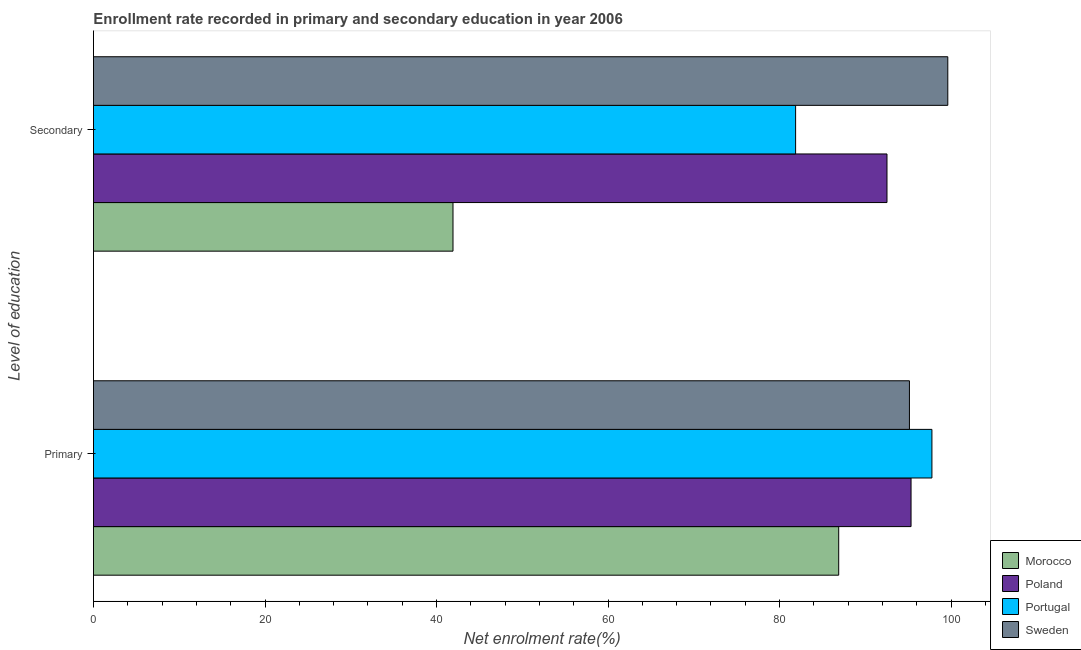How many different coloured bars are there?
Make the answer very short. 4. What is the label of the 1st group of bars from the top?
Keep it short and to the point. Secondary. What is the enrollment rate in primary education in Poland?
Provide a succinct answer. 95.33. Across all countries, what is the maximum enrollment rate in secondary education?
Offer a very short reply. 99.61. Across all countries, what is the minimum enrollment rate in primary education?
Offer a terse response. 86.89. In which country was the enrollment rate in primary education minimum?
Provide a short and direct response. Morocco. What is the total enrollment rate in primary education in the graph?
Your response must be concise. 375.13. What is the difference between the enrollment rate in primary education in Poland and that in Sweden?
Offer a terse response. 0.19. What is the difference between the enrollment rate in primary education in Poland and the enrollment rate in secondary education in Portugal?
Keep it short and to the point. 13.46. What is the average enrollment rate in primary education per country?
Keep it short and to the point. 93.78. What is the difference between the enrollment rate in secondary education and enrollment rate in primary education in Portugal?
Your answer should be compact. -15.89. What is the ratio of the enrollment rate in primary education in Morocco to that in Portugal?
Provide a succinct answer. 0.89. What does the 4th bar from the top in Primary represents?
Keep it short and to the point. Morocco. How many bars are there?
Your response must be concise. 8. How many countries are there in the graph?
Keep it short and to the point. 4. What is the difference between two consecutive major ticks on the X-axis?
Provide a succinct answer. 20. Does the graph contain grids?
Ensure brevity in your answer.  No. Where does the legend appear in the graph?
Ensure brevity in your answer.  Bottom right. What is the title of the graph?
Offer a terse response. Enrollment rate recorded in primary and secondary education in year 2006. What is the label or title of the X-axis?
Your answer should be compact. Net enrolment rate(%). What is the label or title of the Y-axis?
Your response must be concise. Level of education. What is the Net enrolment rate(%) in Morocco in Primary?
Provide a succinct answer. 86.89. What is the Net enrolment rate(%) of Poland in Primary?
Your response must be concise. 95.33. What is the Net enrolment rate(%) of Portugal in Primary?
Your answer should be very brief. 97.76. What is the Net enrolment rate(%) of Sweden in Primary?
Keep it short and to the point. 95.14. What is the Net enrolment rate(%) in Morocco in Secondary?
Make the answer very short. 41.92. What is the Net enrolment rate(%) of Poland in Secondary?
Your answer should be very brief. 92.52. What is the Net enrolment rate(%) of Portugal in Secondary?
Offer a terse response. 81.87. What is the Net enrolment rate(%) in Sweden in Secondary?
Provide a short and direct response. 99.61. Across all Level of education, what is the maximum Net enrolment rate(%) in Morocco?
Give a very brief answer. 86.89. Across all Level of education, what is the maximum Net enrolment rate(%) of Poland?
Give a very brief answer. 95.33. Across all Level of education, what is the maximum Net enrolment rate(%) of Portugal?
Your answer should be compact. 97.76. Across all Level of education, what is the maximum Net enrolment rate(%) of Sweden?
Offer a terse response. 99.61. Across all Level of education, what is the minimum Net enrolment rate(%) in Morocco?
Give a very brief answer. 41.92. Across all Level of education, what is the minimum Net enrolment rate(%) in Poland?
Your answer should be very brief. 92.52. Across all Level of education, what is the minimum Net enrolment rate(%) of Portugal?
Your answer should be very brief. 81.87. Across all Level of education, what is the minimum Net enrolment rate(%) of Sweden?
Offer a very short reply. 95.14. What is the total Net enrolment rate(%) in Morocco in the graph?
Offer a terse response. 128.82. What is the total Net enrolment rate(%) of Poland in the graph?
Ensure brevity in your answer.  187.85. What is the total Net enrolment rate(%) of Portugal in the graph?
Make the answer very short. 179.63. What is the total Net enrolment rate(%) of Sweden in the graph?
Ensure brevity in your answer.  194.76. What is the difference between the Net enrolment rate(%) in Morocco in Primary and that in Secondary?
Keep it short and to the point. 44.97. What is the difference between the Net enrolment rate(%) of Poland in Primary and that in Secondary?
Provide a short and direct response. 2.81. What is the difference between the Net enrolment rate(%) in Portugal in Primary and that in Secondary?
Provide a short and direct response. 15.89. What is the difference between the Net enrolment rate(%) of Sweden in Primary and that in Secondary?
Your response must be concise. -4.47. What is the difference between the Net enrolment rate(%) in Morocco in Primary and the Net enrolment rate(%) in Poland in Secondary?
Provide a short and direct response. -5.63. What is the difference between the Net enrolment rate(%) in Morocco in Primary and the Net enrolment rate(%) in Portugal in Secondary?
Your response must be concise. 5.02. What is the difference between the Net enrolment rate(%) of Morocco in Primary and the Net enrolment rate(%) of Sweden in Secondary?
Provide a short and direct response. -12.72. What is the difference between the Net enrolment rate(%) of Poland in Primary and the Net enrolment rate(%) of Portugal in Secondary?
Give a very brief answer. 13.46. What is the difference between the Net enrolment rate(%) of Poland in Primary and the Net enrolment rate(%) of Sweden in Secondary?
Ensure brevity in your answer.  -4.29. What is the difference between the Net enrolment rate(%) in Portugal in Primary and the Net enrolment rate(%) in Sweden in Secondary?
Give a very brief answer. -1.85. What is the average Net enrolment rate(%) of Morocco per Level of education?
Ensure brevity in your answer.  64.41. What is the average Net enrolment rate(%) in Poland per Level of education?
Your response must be concise. 93.93. What is the average Net enrolment rate(%) in Portugal per Level of education?
Ensure brevity in your answer.  89.82. What is the average Net enrolment rate(%) in Sweden per Level of education?
Ensure brevity in your answer.  97.38. What is the difference between the Net enrolment rate(%) of Morocco and Net enrolment rate(%) of Poland in Primary?
Your answer should be very brief. -8.44. What is the difference between the Net enrolment rate(%) of Morocco and Net enrolment rate(%) of Portugal in Primary?
Your response must be concise. -10.87. What is the difference between the Net enrolment rate(%) in Morocco and Net enrolment rate(%) in Sweden in Primary?
Make the answer very short. -8.25. What is the difference between the Net enrolment rate(%) of Poland and Net enrolment rate(%) of Portugal in Primary?
Provide a succinct answer. -2.43. What is the difference between the Net enrolment rate(%) in Poland and Net enrolment rate(%) in Sweden in Primary?
Your response must be concise. 0.19. What is the difference between the Net enrolment rate(%) of Portugal and Net enrolment rate(%) of Sweden in Primary?
Your response must be concise. 2.62. What is the difference between the Net enrolment rate(%) of Morocco and Net enrolment rate(%) of Poland in Secondary?
Offer a very short reply. -50.6. What is the difference between the Net enrolment rate(%) in Morocco and Net enrolment rate(%) in Portugal in Secondary?
Ensure brevity in your answer.  -39.95. What is the difference between the Net enrolment rate(%) of Morocco and Net enrolment rate(%) of Sweden in Secondary?
Give a very brief answer. -57.69. What is the difference between the Net enrolment rate(%) of Poland and Net enrolment rate(%) of Portugal in Secondary?
Make the answer very short. 10.65. What is the difference between the Net enrolment rate(%) of Poland and Net enrolment rate(%) of Sweden in Secondary?
Keep it short and to the point. -7.09. What is the difference between the Net enrolment rate(%) of Portugal and Net enrolment rate(%) of Sweden in Secondary?
Offer a very short reply. -17.75. What is the ratio of the Net enrolment rate(%) in Morocco in Primary to that in Secondary?
Keep it short and to the point. 2.07. What is the ratio of the Net enrolment rate(%) of Poland in Primary to that in Secondary?
Offer a very short reply. 1.03. What is the ratio of the Net enrolment rate(%) of Portugal in Primary to that in Secondary?
Offer a very short reply. 1.19. What is the ratio of the Net enrolment rate(%) of Sweden in Primary to that in Secondary?
Ensure brevity in your answer.  0.96. What is the difference between the highest and the second highest Net enrolment rate(%) of Morocco?
Provide a succinct answer. 44.97. What is the difference between the highest and the second highest Net enrolment rate(%) in Poland?
Your answer should be very brief. 2.81. What is the difference between the highest and the second highest Net enrolment rate(%) of Portugal?
Make the answer very short. 15.89. What is the difference between the highest and the second highest Net enrolment rate(%) of Sweden?
Keep it short and to the point. 4.47. What is the difference between the highest and the lowest Net enrolment rate(%) of Morocco?
Make the answer very short. 44.97. What is the difference between the highest and the lowest Net enrolment rate(%) in Poland?
Your answer should be very brief. 2.81. What is the difference between the highest and the lowest Net enrolment rate(%) of Portugal?
Offer a terse response. 15.89. What is the difference between the highest and the lowest Net enrolment rate(%) in Sweden?
Give a very brief answer. 4.47. 